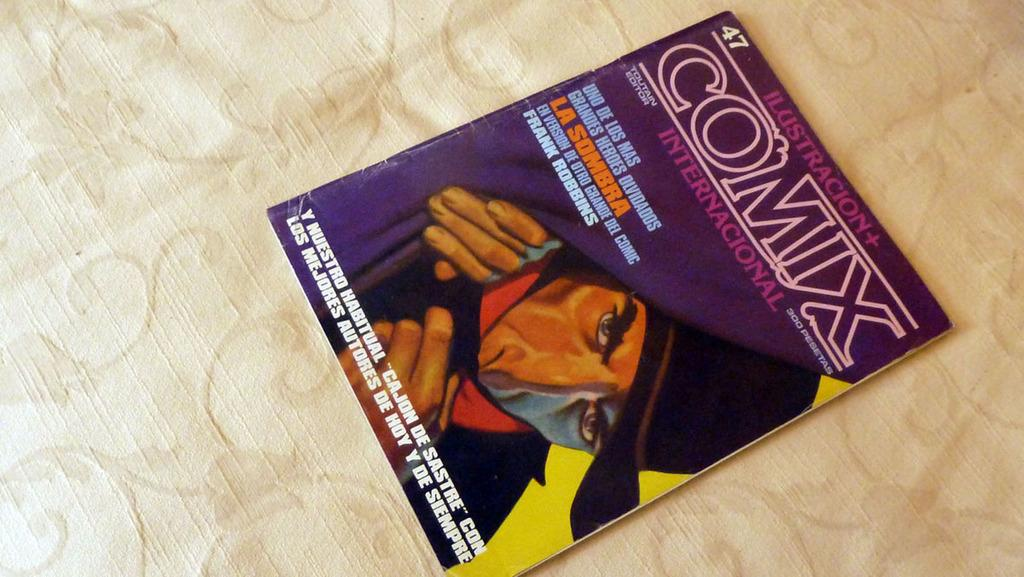Provide a one-sentence caption for the provided image. A cover of Comix with a man showed peeking behind a curtain. 